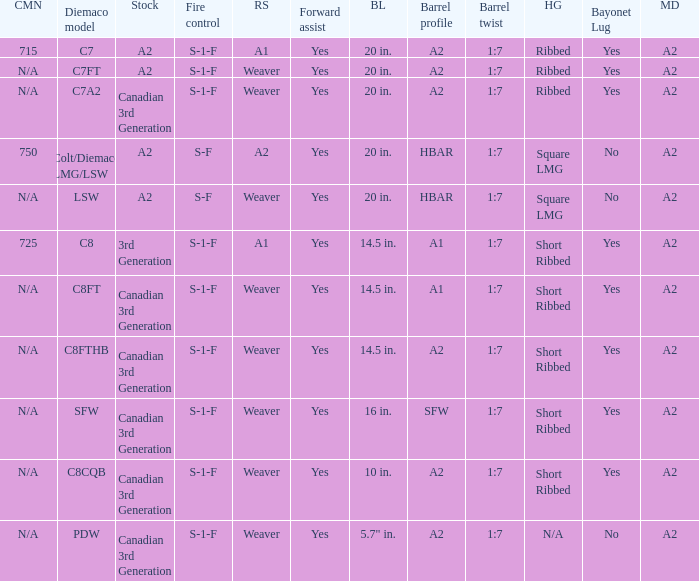Which Hand guards has a Barrel profile of a2 and a Rear sight of weaver? Ribbed, Ribbed, Short Ribbed, Short Ribbed, N/A. 